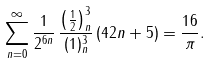<formula> <loc_0><loc_0><loc_500><loc_500>\sum _ { n = 0 } ^ { \infty } \frac { 1 } { 2 ^ { 6 n } } \, \frac { \left ( \frac { 1 } { 2 } \right ) _ { n } ^ { 3 } } { ( 1 ) _ { n } ^ { 3 } } \, ( 4 2 n + 5 ) = \frac { 1 6 } { \pi } .</formula> 